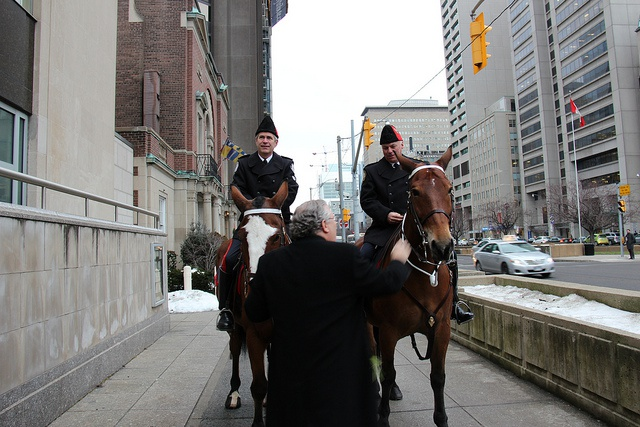Describe the objects in this image and their specific colors. I can see people in black, darkgray, gray, and lightpink tones, horse in black, maroon, gray, and brown tones, horse in black, lightgray, maroon, and gray tones, people in black, gray, darkgray, and maroon tones, and people in black, gray, and maroon tones in this image. 